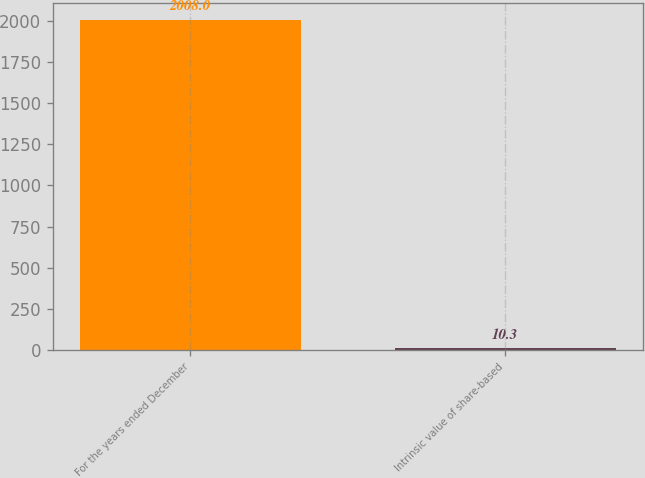<chart> <loc_0><loc_0><loc_500><loc_500><bar_chart><fcel>For the years ended December<fcel>Intrinsic value of share-based<nl><fcel>2008<fcel>10.3<nl></chart> 